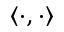Convert formula to latex. <formula><loc_0><loc_0><loc_500><loc_500>\left < \cdot , \cdot \right ></formula> 